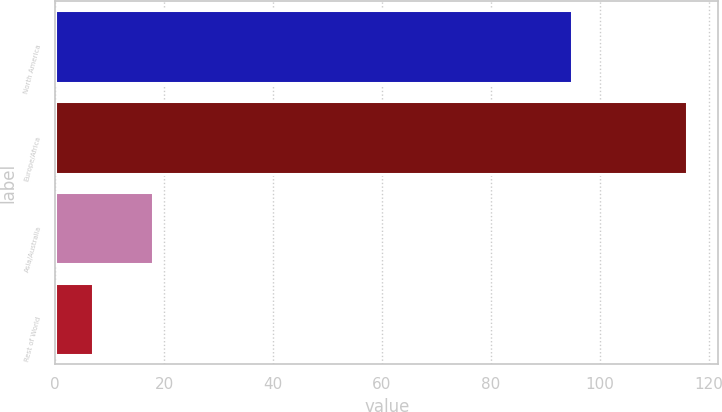<chart> <loc_0><loc_0><loc_500><loc_500><bar_chart><fcel>North America<fcel>Europe/Africa<fcel>Asia/Australia<fcel>Rest of World<nl><fcel>95<fcel>116<fcel>17.9<fcel>7<nl></chart> 